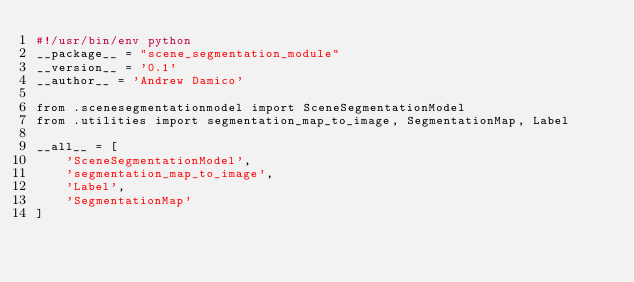Convert code to text. <code><loc_0><loc_0><loc_500><loc_500><_Python_>#!/usr/bin/env python
__package__ = "scene_segmentation_module"
__version__ = '0.1'
__author__ = 'Andrew Damico'

from .scenesegmentationmodel import SceneSegmentationModel
from .utilities import segmentation_map_to_image, SegmentationMap, Label

__all__ = [
    'SceneSegmentationModel',
    'segmentation_map_to_image',
    'Label',
    'SegmentationMap'
]
</code> 